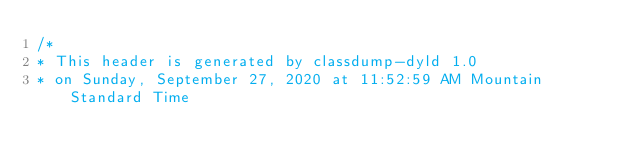Convert code to text. <code><loc_0><loc_0><loc_500><loc_500><_C_>/*
* This header is generated by classdump-dyld 1.0
* on Sunday, September 27, 2020 at 11:52:59 AM Mountain Standard Time</code> 